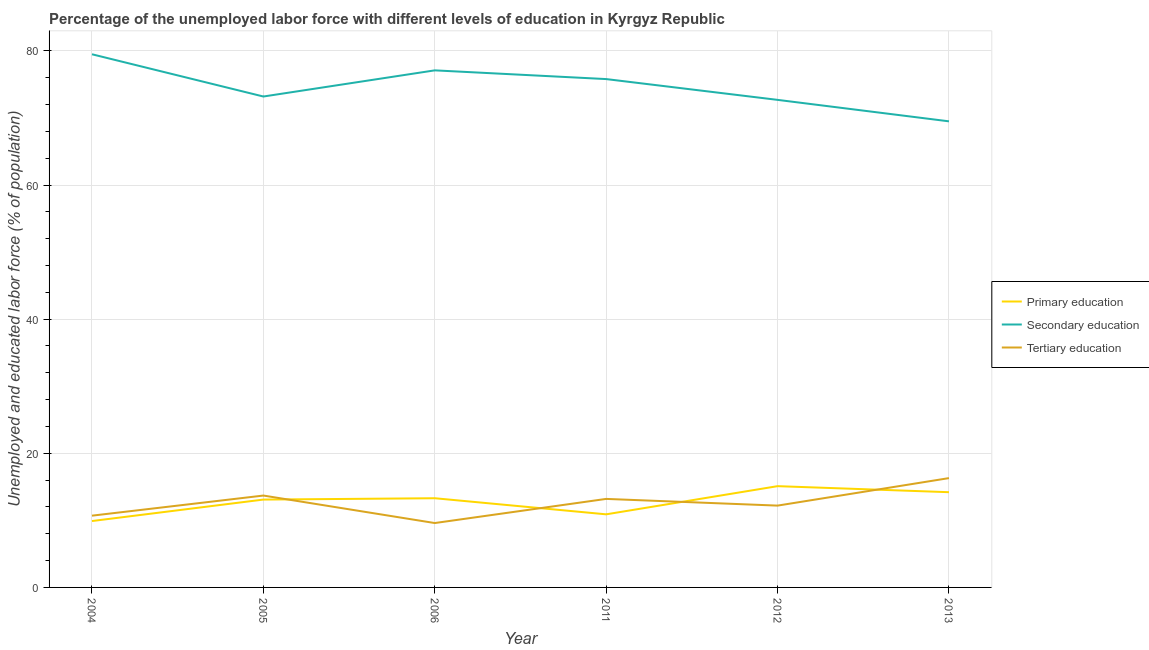How many different coloured lines are there?
Provide a succinct answer. 3. Does the line corresponding to percentage of labor force who received tertiary education intersect with the line corresponding to percentage of labor force who received primary education?
Give a very brief answer. Yes. Is the number of lines equal to the number of legend labels?
Ensure brevity in your answer.  Yes. What is the percentage of labor force who received secondary education in 2006?
Keep it short and to the point. 77.1. Across all years, what is the maximum percentage of labor force who received primary education?
Provide a succinct answer. 15.1. Across all years, what is the minimum percentage of labor force who received tertiary education?
Ensure brevity in your answer.  9.6. In which year was the percentage of labor force who received primary education minimum?
Offer a very short reply. 2004. What is the total percentage of labor force who received secondary education in the graph?
Your response must be concise. 447.8. What is the difference between the percentage of labor force who received primary education in 2004 and that in 2012?
Provide a short and direct response. -5.2. What is the difference between the percentage of labor force who received secondary education in 2011 and the percentage of labor force who received tertiary education in 2004?
Provide a succinct answer. 65.1. What is the average percentage of labor force who received secondary education per year?
Your response must be concise. 74.63. In the year 2012, what is the difference between the percentage of labor force who received secondary education and percentage of labor force who received primary education?
Keep it short and to the point. 57.6. What is the ratio of the percentage of labor force who received secondary education in 2005 to that in 2013?
Offer a terse response. 1.05. Is the difference between the percentage of labor force who received primary education in 2004 and 2013 greater than the difference between the percentage of labor force who received secondary education in 2004 and 2013?
Your answer should be very brief. No. What is the difference between the highest and the second highest percentage of labor force who received primary education?
Offer a very short reply. 0.9. What is the difference between the highest and the lowest percentage of labor force who received primary education?
Offer a terse response. 5.2. Is the sum of the percentage of labor force who received primary education in 2005 and 2006 greater than the maximum percentage of labor force who received secondary education across all years?
Give a very brief answer. No. Is the percentage of labor force who received tertiary education strictly greater than the percentage of labor force who received secondary education over the years?
Your answer should be very brief. No. Is the percentage of labor force who received primary education strictly less than the percentage of labor force who received tertiary education over the years?
Your response must be concise. No. How many years are there in the graph?
Offer a very short reply. 6. Are the values on the major ticks of Y-axis written in scientific E-notation?
Offer a terse response. No. Does the graph contain any zero values?
Keep it short and to the point. No. Does the graph contain grids?
Give a very brief answer. Yes. What is the title of the graph?
Your response must be concise. Percentage of the unemployed labor force with different levels of education in Kyrgyz Republic. What is the label or title of the X-axis?
Offer a terse response. Year. What is the label or title of the Y-axis?
Your answer should be compact. Unemployed and educated labor force (% of population). What is the Unemployed and educated labor force (% of population) of Primary education in 2004?
Offer a terse response. 9.9. What is the Unemployed and educated labor force (% of population) in Secondary education in 2004?
Keep it short and to the point. 79.5. What is the Unemployed and educated labor force (% of population) of Tertiary education in 2004?
Your answer should be very brief. 10.7. What is the Unemployed and educated labor force (% of population) in Primary education in 2005?
Keep it short and to the point. 13.1. What is the Unemployed and educated labor force (% of population) of Secondary education in 2005?
Your answer should be very brief. 73.2. What is the Unemployed and educated labor force (% of population) in Tertiary education in 2005?
Give a very brief answer. 13.7. What is the Unemployed and educated labor force (% of population) of Primary education in 2006?
Provide a short and direct response. 13.3. What is the Unemployed and educated labor force (% of population) in Secondary education in 2006?
Your answer should be very brief. 77.1. What is the Unemployed and educated labor force (% of population) of Tertiary education in 2006?
Offer a terse response. 9.6. What is the Unemployed and educated labor force (% of population) of Primary education in 2011?
Your answer should be very brief. 10.9. What is the Unemployed and educated labor force (% of population) of Secondary education in 2011?
Your answer should be compact. 75.8. What is the Unemployed and educated labor force (% of population) of Tertiary education in 2011?
Ensure brevity in your answer.  13.2. What is the Unemployed and educated labor force (% of population) in Primary education in 2012?
Provide a succinct answer. 15.1. What is the Unemployed and educated labor force (% of population) of Secondary education in 2012?
Offer a very short reply. 72.7. What is the Unemployed and educated labor force (% of population) of Tertiary education in 2012?
Offer a terse response. 12.2. What is the Unemployed and educated labor force (% of population) of Primary education in 2013?
Offer a very short reply. 14.2. What is the Unemployed and educated labor force (% of population) of Secondary education in 2013?
Make the answer very short. 69.5. What is the Unemployed and educated labor force (% of population) of Tertiary education in 2013?
Your answer should be very brief. 16.3. Across all years, what is the maximum Unemployed and educated labor force (% of population) of Primary education?
Give a very brief answer. 15.1. Across all years, what is the maximum Unemployed and educated labor force (% of population) in Secondary education?
Provide a succinct answer. 79.5. Across all years, what is the maximum Unemployed and educated labor force (% of population) in Tertiary education?
Offer a very short reply. 16.3. Across all years, what is the minimum Unemployed and educated labor force (% of population) of Primary education?
Your answer should be compact. 9.9. Across all years, what is the minimum Unemployed and educated labor force (% of population) in Secondary education?
Your answer should be compact. 69.5. Across all years, what is the minimum Unemployed and educated labor force (% of population) in Tertiary education?
Give a very brief answer. 9.6. What is the total Unemployed and educated labor force (% of population) in Primary education in the graph?
Provide a succinct answer. 76.5. What is the total Unemployed and educated labor force (% of population) in Secondary education in the graph?
Your answer should be very brief. 447.8. What is the total Unemployed and educated labor force (% of population) of Tertiary education in the graph?
Your response must be concise. 75.7. What is the difference between the Unemployed and educated labor force (% of population) in Primary education in 2004 and that in 2006?
Ensure brevity in your answer.  -3.4. What is the difference between the Unemployed and educated labor force (% of population) in Secondary education in 2004 and that in 2006?
Provide a succinct answer. 2.4. What is the difference between the Unemployed and educated labor force (% of population) in Tertiary education in 2004 and that in 2006?
Offer a very short reply. 1.1. What is the difference between the Unemployed and educated labor force (% of population) of Secondary education in 2004 and that in 2011?
Your answer should be compact. 3.7. What is the difference between the Unemployed and educated labor force (% of population) of Secondary education in 2004 and that in 2012?
Give a very brief answer. 6.8. What is the difference between the Unemployed and educated labor force (% of population) of Tertiary education in 2004 and that in 2012?
Give a very brief answer. -1.5. What is the difference between the Unemployed and educated labor force (% of population) in Primary education in 2004 and that in 2013?
Keep it short and to the point. -4.3. What is the difference between the Unemployed and educated labor force (% of population) in Secondary education in 2005 and that in 2006?
Provide a succinct answer. -3.9. What is the difference between the Unemployed and educated labor force (% of population) in Primary education in 2005 and that in 2011?
Ensure brevity in your answer.  2.2. What is the difference between the Unemployed and educated labor force (% of population) in Secondary education in 2005 and that in 2011?
Give a very brief answer. -2.6. What is the difference between the Unemployed and educated labor force (% of population) in Primary education in 2005 and that in 2012?
Your answer should be very brief. -2. What is the difference between the Unemployed and educated labor force (% of population) of Secondary education in 2005 and that in 2012?
Give a very brief answer. 0.5. What is the difference between the Unemployed and educated labor force (% of population) in Tertiary education in 2005 and that in 2012?
Your answer should be very brief. 1.5. What is the difference between the Unemployed and educated labor force (% of population) of Primary education in 2005 and that in 2013?
Your response must be concise. -1.1. What is the difference between the Unemployed and educated labor force (% of population) of Tertiary education in 2005 and that in 2013?
Give a very brief answer. -2.6. What is the difference between the Unemployed and educated labor force (% of population) in Primary education in 2006 and that in 2011?
Offer a very short reply. 2.4. What is the difference between the Unemployed and educated labor force (% of population) in Tertiary education in 2006 and that in 2011?
Give a very brief answer. -3.6. What is the difference between the Unemployed and educated labor force (% of population) in Primary education in 2006 and that in 2012?
Give a very brief answer. -1.8. What is the difference between the Unemployed and educated labor force (% of population) of Secondary education in 2006 and that in 2012?
Ensure brevity in your answer.  4.4. What is the difference between the Unemployed and educated labor force (% of population) in Tertiary education in 2006 and that in 2012?
Make the answer very short. -2.6. What is the difference between the Unemployed and educated labor force (% of population) in Primary education in 2006 and that in 2013?
Provide a succinct answer. -0.9. What is the difference between the Unemployed and educated labor force (% of population) in Secondary education in 2011 and that in 2012?
Offer a terse response. 3.1. What is the difference between the Unemployed and educated labor force (% of population) of Primary education in 2011 and that in 2013?
Provide a succinct answer. -3.3. What is the difference between the Unemployed and educated labor force (% of population) in Secondary education in 2011 and that in 2013?
Provide a succinct answer. 6.3. What is the difference between the Unemployed and educated labor force (% of population) of Tertiary education in 2011 and that in 2013?
Make the answer very short. -3.1. What is the difference between the Unemployed and educated labor force (% of population) in Primary education in 2012 and that in 2013?
Your response must be concise. 0.9. What is the difference between the Unemployed and educated labor force (% of population) of Secondary education in 2012 and that in 2013?
Make the answer very short. 3.2. What is the difference between the Unemployed and educated labor force (% of population) of Primary education in 2004 and the Unemployed and educated labor force (% of population) of Secondary education in 2005?
Make the answer very short. -63.3. What is the difference between the Unemployed and educated labor force (% of population) in Secondary education in 2004 and the Unemployed and educated labor force (% of population) in Tertiary education in 2005?
Give a very brief answer. 65.8. What is the difference between the Unemployed and educated labor force (% of population) in Primary education in 2004 and the Unemployed and educated labor force (% of population) in Secondary education in 2006?
Your answer should be compact. -67.2. What is the difference between the Unemployed and educated labor force (% of population) in Primary education in 2004 and the Unemployed and educated labor force (% of population) in Tertiary education in 2006?
Your answer should be compact. 0.3. What is the difference between the Unemployed and educated labor force (% of population) in Secondary education in 2004 and the Unemployed and educated labor force (% of population) in Tertiary education in 2006?
Provide a short and direct response. 69.9. What is the difference between the Unemployed and educated labor force (% of population) of Primary education in 2004 and the Unemployed and educated labor force (% of population) of Secondary education in 2011?
Give a very brief answer. -65.9. What is the difference between the Unemployed and educated labor force (% of population) in Secondary education in 2004 and the Unemployed and educated labor force (% of population) in Tertiary education in 2011?
Give a very brief answer. 66.3. What is the difference between the Unemployed and educated labor force (% of population) in Primary education in 2004 and the Unemployed and educated labor force (% of population) in Secondary education in 2012?
Offer a very short reply. -62.8. What is the difference between the Unemployed and educated labor force (% of population) of Primary education in 2004 and the Unemployed and educated labor force (% of population) of Tertiary education in 2012?
Make the answer very short. -2.3. What is the difference between the Unemployed and educated labor force (% of population) of Secondary education in 2004 and the Unemployed and educated labor force (% of population) of Tertiary education in 2012?
Ensure brevity in your answer.  67.3. What is the difference between the Unemployed and educated labor force (% of population) in Primary education in 2004 and the Unemployed and educated labor force (% of population) in Secondary education in 2013?
Give a very brief answer. -59.6. What is the difference between the Unemployed and educated labor force (% of population) of Secondary education in 2004 and the Unemployed and educated labor force (% of population) of Tertiary education in 2013?
Provide a succinct answer. 63.2. What is the difference between the Unemployed and educated labor force (% of population) of Primary education in 2005 and the Unemployed and educated labor force (% of population) of Secondary education in 2006?
Your response must be concise. -64. What is the difference between the Unemployed and educated labor force (% of population) of Secondary education in 2005 and the Unemployed and educated labor force (% of population) of Tertiary education in 2006?
Offer a very short reply. 63.6. What is the difference between the Unemployed and educated labor force (% of population) of Primary education in 2005 and the Unemployed and educated labor force (% of population) of Secondary education in 2011?
Ensure brevity in your answer.  -62.7. What is the difference between the Unemployed and educated labor force (% of population) of Primary education in 2005 and the Unemployed and educated labor force (% of population) of Secondary education in 2012?
Give a very brief answer. -59.6. What is the difference between the Unemployed and educated labor force (% of population) of Primary education in 2005 and the Unemployed and educated labor force (% of population) of Tertiary education in 2012?
Offer a terse response. 0.9. What is the difference between the Unemployed and educated labor force (% of population) of Primary education in 2005 and the Unemployed and educated labor force (% of population) of Secondary education in 2013?
Your answer should be very brief. -56.4. What is the difference between the Unemployed and educated labor force (% of population) in Secondary education in 2005 and the Unemployed and educated labor force (% of population) in Tertiary education in 2013?
Keep it short and to the point. 56.9. What is the difference between the Unemployed and educated labor force (% of population) of Primary education in 2006 and the Unemployed and educated labor force (% of population) of Secondary education in 2011?
Offer a terse response. -62.5. What is the difference between the Unemployed and educated labor force (% of population) in Primary education in 2006 and the Unemployed and educated labor force (% of population) in Tertiary education in 2011?
Make the answer very short. 0.1. What is the difference between the Unemployed and educated labor force (% of population) of Secondary education in 2006 and the Unemployed and educated labor force (% of population) of Tertiary education in 2011?
Your answer should be very brief. 63.9. What is the difference between the Unemployed and educated labor force (% of population) in Primary education in 2006 and the Unemployed and educated labor force (% of population) in Secondary education in 2012?
Give a very brief answer. -59.4. What is the difference between the Unemployed and educated labor force (% of population) in Secondary education in 2006 and the Unemployed and educated labor force (% of population) in Tertiary education in 2012?
Keep it short and to the point. 64.9. What is the difference between the Unemployed and educated labor force (% of population) of Primary education in 2006 and the Unemployed and educated labor force (% of population) of Secondary education in 2013?
Keep it short and to the point. -56.2. What is the difference between the Unemployed and educated labor force (% of population) of Primary education in 2006 and the Unemployed and educated labor force (% of population) of Tertiary education in 2013?
Keep it short and to the point. -3. What is the difference between the Unemployed and educated labor force (% of population) in Secondary education in 2006 and the Unemployed and educated labor force (% of population) in Tertiary education in 2013?
Give a very brief answer. 60.8. What is the difference between the Unemployed and educated labor force (% of population) in Primary education in 2011 and the Unemployed and educated labor force (% of population) in Secondary education in 2012?
Your answer should be very brief. -61.8. What is the difference between the Unemployed and educated labor force (% of population) of Secondary education in 2011 and the Unemployed and educated labor force (% of population) of Tertiary education in 2012?
Give a very brief answer. 63.6. What is the difference between the Unemployed and educated labor force (% of population) of Primary education in 2011 and the Unemployed and educated labor force (% of population) of Secondary education in 2013?
Keep it short and to the point. -58.6. What is the difference between the Unemployed and educated labor force (% of population) in Primary education in 2011 and the Unemployed and educated labor force (% of population) in Tertiary education in 2013?
Offer a terse response. -5.4. What is the difference between the Unemployed and educated labor force (% of population) of Secondary education in 2011 and the Unemployed and educated labor force (% of population) of Tertiary education in 2013?
Provide a succinct answer. 59.5. What is the difference between the Unemployed and educated labor force (% of population) in Primary education in 2012 and the Unemployed and educated labor force (% of population) in Secondary education in 2013?
Your answer should be very brief. -54.4. What is the difference between the Unemployed and educated labor force (% of population) in Primary education in 2012 and the Unemployed and educated labor force (% of population) in Tertiary education in 2013?
Offer a terse response. -1.2. What is the difference between the Unemployed and educated labor force (% of population) in Secondary education in 2012 and the Unemployed and educated labor force (% of population) in Tertiary education in 2013?
Offer a terse response. 56.4. What is the average Unemployed and educated labor force (% of population) of Primary education per year?
Make the answer very short. 12.75. What is the average Unemployed and educated labor force (% of population) of Secondary education per year?
Provide a succinct answer. 74.63. What is the average Unemployed and educated labor force (% of population) of Tertiary education per year?
Your answer should be very brief. 12.62. In the year 2004, what is the difference between the Unemployed and educated labor force (% of population) in Primary education and Unemployed and educated labor force (% of population) in Secondary education?
Offer a very short reply. -69.6. In the year 2004, what is the difference between the Unemployed and educated labor force (% of population) of Secondary education and Unemployed and educated labor force (% of population) of Tertiary education?
Your answer should be compact. 68.8. In the year 2005, what is the difference between the Unemployed and educated labor force (% of population) in Primary education and Unemployed and educated labor force (% of population) in Secondary education?
Make the answer very short. -60.1. In the year 2005, what is the difference between the Unemployed and educated labor force (% of population) in Primary education and Unemployed and educated labor force (% of population) in Tertiary education?
Your response must be concise. -0.6. In the year 2005, what is the difference between the Unemployed and educated labor force (% of population) in Secondary education and Unemployed and educated labor force (% of population) in Tertiary education?
Offer a terse response. 59.5. In the year 2006, what is the difference between the Unemployed and educated labor force (% of population) in Primary education and Unemployed and educated labor force (% of population) in Secondary education?
Offer a terse response. -63.8. In the year 2006, what is the difference between the Unemployed and educated labor force (% of population) in Primary education and Unemployed and educated labor force (% of population) in Tertiary education?
Give a very brief answer. 3.7. In the year 2006, what is the difference between the Unemployed and educated labor force (% of population) in Secondary education and Unemployed and educated labor force (% of population) in Tertiary education?
Give a very brief answer. 67.5. In the year 2011, what is the difference between the Unemployed and educated labor force (% of population) of Primary education and Unemployed and educated labor force (% of population) of Secondary education?
Offer a very short reply. -64.9. In the year 2011, what is the difference between the Unemployed and educated labor force (% of population) in Primary education and Unemployed and educated labor force (% of population) in Tertiary education?
Offer a very short reply. -2.3. In the year 2011, what is the difference between the Unemployed and educated labor force (% of population) of Secondary education and Unemployed and educated labor force (% of population) of Tertiary education?
Your answer should be compact. 62.6. In the year 2012, what is the difference between the Unemployed and educated labor force (% of population) of Primary education and Unemployed and educated labor force (% of population) of Secondary education?
Keep it short and to the point. -57.6. In the year 2012, what is the difference between the Unemployed and educated labor force (% of population) of Primary education and Unemployed and educated labor force (% of population) of Tertiary education?
Offer a very short reply. 2.9. In the year 2012, what is the difference between the Unemployed and educated labor force (% of population) in Secondary education and Unemployed and educated labor force (% of population) in Tertiary education?
Provide a succinct answer. 60.5. In the year 2013, what is the difference between the Unemployed and educated labor force (% of population) in Primary education and Unemployed and educated labor force (% of population) in Secondary education?
Your answer should be very brief. -55.3. In the year 2013, what is the difference between the Unemployed and educated labor force (% of population) in Secondary education and Unemployed and educated labor force (% of population) in Tertiary education?
Offer a very short reply. 53.2. What is the ratio of the Unemployed and educated labor force (% of population) of Primary education in 2004 to that in 2005?
Provide a succinct answer. 0.76. What is the ratio of the Unemployed and educated labor force (% of population) of Secondary education in 2004 to that in 2005?
Make the answer very short. 1.09. What is the ratio of the Unemployed and educated labor force (% of population) in Tertiary education in 2004 to that in 2005?
Your answer should be compact. 0.78. What is the ratio of the Unemployed and educated labor force (% of population) in Primary education in 2004 to that in 2006?
Provide a succinct answer. 0.74. What is the ratio of the Unemployed and educated labor force (% of population) in Secondary education in 2004 to that in 2006?
Keep it short and to the point. 1.03. What is the ratio of the Unemployed and educated labor force (% of population) in Tertiary education in 2004 to that in 2006?
Your answer should be very brief. 1.11. What is the ratio of the Unemployed and educated labor force (% of population) of Primary education in 2004 to that in 2011?
Offer a very short reply. 0.91. What is the ratio of the Unemployed and educated labor force (% of population) in Secondary education in 2004 to that in 2011?
Provide a short and direct response. 1.05. What is the ratio of the Unemployed and educated labor force (% of population) of Tertiary education in 2004 to that in 2011?
Your answer should be compact. 0.81. What is the ratio of the Unemployed and educated labor force (% of population) in Primary education in 2004 to that in 2012?
Offer a very short reply. 0.66. What is the ratio of the Unemployed and educated labor force (% of population) in Secondary education in 2004 to that in 2012?
Provide a succinct answer. 1.09. What is the ratio of the Unemployed and educated labor force (% of population) of Tertiary education in 2004 to that in 2012?
Keep it short and to the point. 0.88. What is the ratio of the Unemployed and educated labor force (% of population) of Primary education in 2004 to that in 2013?
Your response must be concise. 0.7. What is the ratio of the Unemployed and educated labor force (% of population) in Secondary education in 2004 to that in 2013?
Provide a succinct answer. 1.14. What is the ratio of the Unemployed and educated labor force (% of population) in Tertiary education in 2004 to that in 2013?
Offer a very short reply. 0.66. What is the ratio of the Unemployed and educated labor force (% of population) of Secondary education in 2005 to that in 2006?
Offer a very short reply. 0.95. What is the ratio of the Unemployed and educated labor force (% of population) of Tertiary education in 2005 to that in 2006?
Provide a short and direct response. 1.43. What is the ratio of the Unemployed and educated labor force (% of population) of Primary education in 2005 to that in 2011?
Give a very brief answer. 1.2. What is the ratio of the Unemployed and educated labor force (% of population) of Secondary education in 2005 to that in 2011?
Ensure brevity in your answer.  0.97. What is the ratio of the Unemployed and educated labor force (% of population) in Tertiary education in 2005 to that in 2011?
Provide a short and direct response. 1.04. What is the ratio of the Unemployed and educated labor force (% of population) in Primary education in 2005 to that in 2012?
Give a very brief answer. 0.87. What is the ratio of the Unemployed and educated labor force (% of population) of Secondary education in 2005 to that in 2012?
Give a very brief answer. 1.01. What is the ratio of the Unemployed and educated labor force (% of population) in Tertiary education in 2005 to that in 2012?
Ensure brevity in your answer.  1.12. What is the ratio of the Unemployed and educated labor force (% of population) in Primary education in 2005 to that in 2013?
Offer a very short reply. 0.92. What is the ratio of the Unemployed and educated labor force (% of population) in Secondary education in 2005 to that in 2013?
Give a very brief answer. 1.05. What is the ratio of the Unemployed and educated labor force (% of population) in Tertiary education in 2005 to that in 2013?
Keep it short and to the point. 0.84. What is the ratio of the Unemployed and educated labor force (% of population) in Primary education in 2006 to that in 2011?
Give a very brief answer. 1.22. What is the ratio of the Unemployed and educated labor force (% of population) in Secondary education in 2006 to that in 2011?
Give a very brief answer. 1.02. What is the ratio of the Unemployed and educated labor force (% of population) of Tertiary education in 2006 to that in 2011?
Ensure brevity in your answer.  0.73. What is the ratio of the Unemployed and educated labor force (% of population) in Primary education in 2006 to that in 2012?
Provide a succinct answer. 0.88. What is the ratio of the Unemployed and educated labor force (% of population) in Secondary education in 2006 to that in 2012?
Make the answer very short. 1.06. What is the ratio of the Unemployed and educated labor force (% of population) in Tertiary education in 2006 to that in 2012?
Provide a short and direct response. 0.79. What is the ratio of the Unemployed and educated labor force (% of population) of Primary education in 2006 to that in 2013?
Give a very brief answer. 0.94. What is the ratio of the Unemployed and educated labor force (% of population) of Secondary education in 2006 to that in 2013?
Provide a short and direct response. 1.11. What is the ratio of the Unemployed and educated labor force (% of population) in Tertiary education in 2006 to that in 2013?
Ensure brevity in your answer.  0.59. What is the ratio of the Unemployed and educated labor force (% of population) of Primary education in 2011 to that in 2012?
Ensure brevity in your answer.  0.72. What is the ratio of the Unemployed and educated labor force (% of population) of Secondary education in 2011 to that in 2012?
Your response must be concise. 1.04. What is the ratio of the Unemployed and educated labor force (% of population) of Tertiary education in 2011 to that in 2012?
Your answer should be compact. 1.08. What is the ratio of the Unemployed and educated labor force (% of population) in Primary education in 2011 to that in 2013?
Keep it short and to the point. 0.77. What is the ratio of the Unemployed and educated labor force (% of population) in Secondary education in 2011 to that in 2013?
Offer a terse response. 1.09. What is the ratio of the Unemployed and educated labor force (% of population) of Tertiary education in 2011 to that in 2013?
Offer a terse response. 0.81. What is the ratio of the Unemployed and educated labor force (% of population) of Primary education in 2012 to that in 2013?
Offer a very short reply. 1.06. What is the ratio of the Unemployed and educated labor force (% of population) of Secondary education in 2012 to that in 2013?
Offer a very short reply. 1.05. What is the ratio of the Unemployed and educated labor force (% of population) in Tertiary education in 2012 to that in 2013?
Offer a terse response. 0.75. What is the difference between the highest and the second highest Unemployed and educated labor force (% of population) of Primary education?
Your response must be concise. 0.9. What is the difference between the highest and the second highest Unemployed and educated labor force (% of population) in Tertiary education?
Make the answer very short. 2.6. What is the difference between the highest and the lowest Unemployed and educated labor force (% of population) in Primary education?
Offer a very short reply. 5.2. What is the difference between the highest and the lowest Unemployed and educated labor force (% of population) of Tertiary education?
Offer a very short reply. 6.7. 